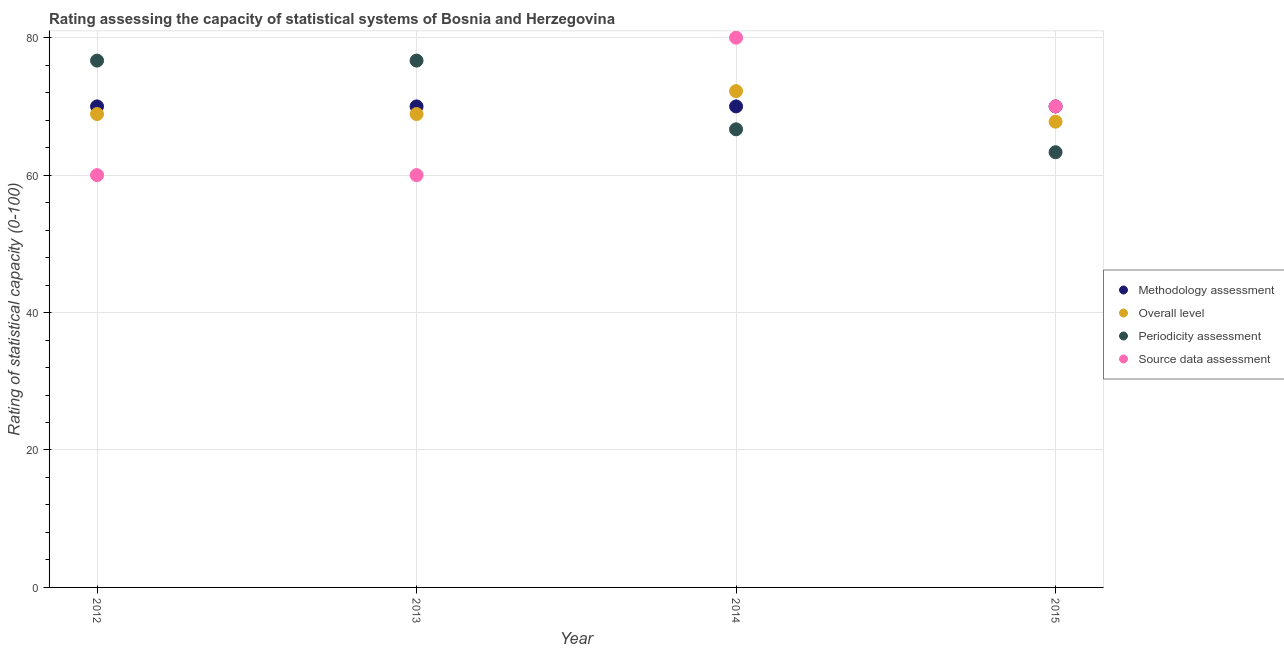What is the methodology assessment rating in 2014?
Make the answer very short. 70. Across all years, what is the maximum methodology assessment rating?
Your answer should be very brief. 70. Across all years, what is the minimum source data assessment rating?
Provide a short and direct response. 60. In which year was the periodicity assessment rating minimum?
Offer a terse response. 2015. What is the total overall level rating in the graph?
Give a very brief answer. 277.78. What is the difference between the source data assessment rating in 2014 and that in 2015?
Make the answer very short. 10. What is the difference between the methodology assessment rating in 2013 and the overall level rating in 2015?
Ensure brevity in your answer.  2.22. What is the average overall level rating per year?
Your answer should be compact. 69.44. In the year 2012, what is the difference between the periodicity assessment rating and methodology assessment rating?
Your response must be concise. 6.67. What is the ratio of the overall level rating in 2014 to that in 2015?
Your response must be concise. 1.07. Is the overall level rating in 2013 less than that in 2014?
Your answer should be compact. Yes. Is the difference between the periodicity assessment rating in 2013 and 2014 greater than the difference between the methodology assessment rating in 2013 and 2014?
Your response must be concise. Yes. What is the difference between the highest and the second highest periodicity assessment rating?
Provide a short and direct response. 3.3333332964957663e-6. What is the difference between the highest and the lowest methodology assessment rating?
Provide a succinct answer. 0. In how many years, is the methodology assessment rating greater than the average methodology assessment rating taken over all years?
Offer a very short reply. 0. Is the methodology assessment rating strictly greater than the periodicity assessment rating over the years?
Ensure brevity in your answer.  No. Is the overall level rating strictly less than the periodicity assessment rating over the years?
Offer a very short reply. No. How many years are there in the graph?
Your response must be concise. 4. What is the difference between two consecutive major ticks on the Y-axis?
Keep it short and to the point. 20. Are the values on the major ticks of Y-axis written in scientific E-notation?
Ensure brevity in your answer.  No. Where does the legend appear in the graph?
Offer a terse response. Center right. How many legend labels are there?
Your response must be concise. 4. What is the title of the graph?
Your answer should be compact. Rating assessing the capacity of statistical systems of Bosnia and Herzegovina. What is the label or title of the Y-axis?
Your answer should be very brief. Rating of statistical capacity (0-100). What is the Rating of statistical capacity (0-100) in Overall level in 2012?
Your answer should be compact. 68.89. What is the Rating of statistical capacity (0-100) of Periodicity assessment in 2012?
Your answer should be compact. 76.67. What is the Rating of statistical capacity (0-100) of Source data assessment in 2012?
Your response must be concise. 60. What is the Rating of statistical capacity (0-100) of Methodology assessment in 2013?
Your response must be concise. 70. What is the Rating of statistical capacity (0-100) in Overall level in 2013?
Ensure brevity in your answer.  68.89. What is the Rating of statistical capacity (0-100) of Periodicity assessment in 2013?
Give a very brief answer. 76.67. What is the Rating of statistical capacity (0-100) of Source data assessment in 2013?
Keep it short and to the point. 60. What is the Rating of statistical capacity (0-100) in Methodology assessment in 2014?
Provide a short and direct response. 70. What is the Rating of statistical capacity (0-100) in Overall level in 2014?
Provide a short and direct response. 72.22. What is the Rating of statistical capacity (0-100) in Periodicity assessment in 2014?
Ensure brevity in your answer.  66.67. What is the Rating of statistical capacity (0-100) of Source data assessment in 2014?
Make the answer very short. 80. What is the Rating of statistical capacity (0-100) in Methodology assessment in 2015?
Offer a terse response. 70. What is the Rating of statistical capacity (0-100) of Overall level in 2015?
Offer a terse response. 67.78. What is the Rating of statistical capacity (0-100) of Periodicity assessment in 2015?
Ensure brevity in your answer.  63.33. Across all years, what is the maximum Rating of statistical capacity (0-100) of Overall level?
Make the answer very short. 72.22. Across all years, what is the maximum Rating of statistical capacity (0-100) of Periodicity assessment?
Your response must be concise. 76.67. Across all years, what is the maximum Rating of statistical capacity (0-100) in Source data assessment?
Provide a short and direct response. 80. Across all years, what is the minimum Rating of statistical capacity (0-100) in Methodology assessment?
Your response must be concise. 70. Across all years, what is the minimum Rating of statistical capacity (0-100) in Overall level?
Ensure brevity in your answer.  67.78. Across all years, what is the minimum Rating of statistical capacity (0-100) of Periodicity assessment?
Ensure brevity in your answer.  63.33. What is the total Rating of statistical capacity (0-100) of Methodology assessment in the graph?
Your response must be concise. 280. What is the total Rating of statistical capacity (0-100) of Overall level in the graph?
Your answer should be very brief. 277.78. What is the total Rating of statistical capacity (0-100) in Periodicity assessment in the graph?
Provide a succinct answer. 283.33. What is the total Rating of statistical capacity (0-100) of Source data assessment in the graph?
Make the answer very short. 270. What is the difference between the Rating of statistical capacity (0-100) in Overall level in 2012 and that in 2013?
Your response must be concise. 0. What is the difference between the Rating of statistical capacity (0-100) of Overall level in 2012 and that in 2014?
Ensure brevity in your answer.  -3.33. What is the difference between the Rating of statistical capacity (0-100) in Source data assessment in 2012 and that in 2014?
Give a very brief answer. -20. What is the difference between the Rating of statistical capacity (0-100) in Periodicity assessment in 2012 and that in 2015?
Ensure brevity in your answer.  13.33. What is the difference between the Rating of statistical capacity (0-100) of Overall level in 2013 and that in 2014?
Provide a short and direct response. -3.33. What is the difference between the Rating of statistical capacity (0-100) in Periodicity assessment in 2013 and that in 2014?
Your response must be concise. 10. What is the difference between the Rating of statistical capacity (0-100) of Periodicity assessment in 2013 and that in 2015?
Offer a terse response. 13.33. What is the difference between the Rating of statistical capacity (0-100) in Source data assessment in 2013 and that in 2015?
Give a very brief answer. -10. What is the difference between the Rating of statistical capacity (0-100) of Overall level in 2014 and that in 2015?
Your answer should be compact. 4.44. What is the difference between the Rating of statistical capacity (0-100) in Periodicity assessment in 2014 and that in 2015?
Offer a terse response. 3.33. What is the difference between the Rating of statistical capacity (0-100) in Methodology assessment in 2012 and the Rating of statistical capacity (0-100) in Overall level in 2013?
Keep it short and to the point. 1.11. What is the difference between the Rating of statistical capacity (0-100) in Methodology assessment in 2012 and the Rating of statistical capacity (0-100) in Periodicity assessment in 2013?
Keep it short and to the point. -6.67. What is the difference between the Rating of statistical capacity (0-100) of Methodology assessment in 2012 and the Rating of statistical capacity (0-100) of Source data assessment in 2013?
Keep it short and to the point. 10. What is the difference between the Rating of statistical capacity (0-100) in Overall level in 2012 and the Rating of statistical capacity (0-100) in Periodicity assessment in 2013?
Give a very brief answer. -7.78. What is the difference between the Rating of statistical capacity (0-100) in Overall level in 2012 and the Rating of statistical capacity (0-100) in Source data assessment in 2013?
Ensure brevity in your answer.  8.89. What is the difference between the Rating of statistical capacity (0-100) of Periodicity assessment in 2012 and the Rating of statistical capacity (0-100) of Source data assessment in 2013?
Provide a short and direct response. 16.67. What is the difference between the Rating of statistical capacity (0-100) of Methodology assessment in 2012 and the Rating of statistical capacity (0-100) of Overall level in 2014?
Offer a very short reply. -2.22. What is the difference between the Rating of statistical capacity (0-100) of Methodology assessment in 2012 and the Rating of statistical capacity (0-100) of Periodicity assessment in 2014?
Ensure brevity in your answer.  3.33. What is the difference between the Rating of statistical capacity (0-100) in Methodology assessment in 2012 and the Rating of statistical capacity (0-100) in Source data assessment in 2014?
Give a very brief answer. -10. What is the difference between the Rating of statistical capacity (0-100) of Overall level in 2012 and the Rating of statistical capacity (0-100) of Periodicity assessment in 2014?
Offer a terse response. 2.22. What is the difference between the Rating of statistical capacity (0-100) in Overall level in 2012 and the Rating of statistical capacity (0-100) in Source data assessment in 2014?
Make the answer very short. -11.11. What is the difference between the Rating of statistical capacity (0-100) of Periodicity assessment in 2012 and the Rating of statistical capacity (0-100) of Source data assessment in 2014?
Offer a very short reply. -3.33. What is the difference between the Rating of statistical capacity (0-100) of Methodology assessment in 2012 and the Rating of statistical capacity (0-100) of Overall level in 2015?
Offer a terse response. 2.22. What is the difference between the Rating of statistical capacity (0-100) in Methodology assessment in 2012 and the Rating of statistical capacity (0-100) in Periodicity assessment in 2015?
Make the answer very short. 6.67. What is the difference between the Rating of statistical capacity (0-100) of Overall level in 2012 and the Rating of statistical capacity (0-100) of Periodicity assessment in 2015?
Your response must be concise. 5.56. What is the difference between the Rating of statistical capacity (0-100) of Overall level in 2012 and the Rating of statistical capacity (0-100) of Source data assessment in 2015?
Provide a succinct answer. -1.11. What is the difference between the Rating of statistical capacity (0-100) of Methodology assessment in 2013 and the Rating of statistical capacity (0-100) of Overall level in 2014?
Offer a very short reply. -2.22. What is the difference between the Rating of statistical capacity (0-100) in Methodology assessment in 2013 and the Rating of statistical capacity (0-100) in Periodicity assessment in 2014?
Offer a terse response. 3.33. What is the difference between the Rating of statistical capacity (0-100) in Methodology assessment in 2013 and the Rating of statistical capacity (0-100) in Source data assessment in 2014?
Offer a very short reply. -10. What is the difference between the Rating of statistical capacity (0-100) of Overall level in 2013 and the Rating of statistical capacity (0-100) of Periodicity assessment in 2014?
Keep it short and to the point. 2.22. What is the difference between the Rating of statistical capacity (0-100) of Overall level in 2013 and the Rating of statistical capacity (0-100) of Source data assessment in 2014?
Make the answer very short. -11.11. What is the difference between the Rating of statistical capacity (0-100) of Periodicity assessment in 2013 and the Rating of statistical capacity (0-100) of Source data assessment in 2014?
Provide a short and direct response. -3.33. What is the difference between the Rating of statistical capacity (0-100) of Methodology assessment in 2013 and the Rating of statistical capacity (0-100) of Overall level in 2015?
Your answer should be very brief. 2.22. What is the difference between the Rating of statistical capacity (0-100) of Methodology assessment in 2013 and the Rating of statistical capacity (0-100) of Periodicity assessment in 2015?
Keep it short and to the point. 6.67. What is the difference between the Rating of statistical capacity (0-100) in Methodology assessment in 2013 and the Rating of statistical capacity (0-100) in Source data assessment in 2015?
Offer a terse response. 0. What is the difference between the Rating of statistical capacity (0-100) in Overall level in 2013 and the Rating of statistical capacity (0-100) in Periodicity assessment in 2015?
Your response must be concise. 5.56. What is the difference between the Rating of statistical capacity (0-100) of Overall level in 2013 and the Rating of statistical capacity (0-100) of Source data assessment in 2015?
Your response must be concise. -1.11. What is the difference between the Rating of statistical capacity (0-100) in Periodicity assessment in 2013 and the Rating of statistical capacity (0-100) in Source data assessment in 2015?
Your response must be concise. 6.67. What is the difference between the Rating of statistical capacity (0-100) of Methodology assessment in 2014 and the Rating of statistical capacity (0-100) of Overall level in 2015?
Your response must be concise. 2.22. What is the difference between the Rating of statistical capacity (0-100) in Methodology assessment in 2014 and the Rating of statistical capacity (0-100) in Periodicity assessment in 2015?
Your response must be concise. 6.67. What is the difference between the Rating of statistical capacity (0-100) in Overall level in 2014 and the Rating of statistical capacity (0-100) in Periodicity assessment in 2015?
Offer a very short reply. 8.89. What is the difference between the Rating of statistical capacity (0-100) of Overall level in 2014 and the Rating of statistical capacity (0-100) of Source data assessment in 2015?
Provide a short and direct response. 2.22. What is the difference between the Rating of statistical capacity (0-100) of Periodicity assessment in 2014 and the Rating of statistical capacity (0-100) of Source data assessment in 2015?
Offer a terse response. -3.33. What is the average Rating of statistical capacity (0-100) in Overall level per year?
Provide a short and direct response. 69.44. What is the average Rating of statistical capacity (0-100) in Periodicity assessment per year?
Your answer should be very brief. 70.83. What is the average Rating of statistical capacity (0-100) of Source data assessment per year?
Ensure brevity in your answer.  67.5. In the year 2012, what is the difference between the Rating of statistical capacity (0-100) of Methodology assessment and Rating of statistical capacity (0-100) of Overall level?
Make the answer very short. 1.11. In the year 2012, what is the difference between the Rating of statistical capacity (0-100) in Methodology assessment and Rating of statistical capacity (0-100) in Periodicity assessment?
Provide a succinct answer. -6.67. In the year 2012, what is the difference between the Rating of statistical capacity (0-100) in Methodology assessment and Rating of statistical capacity (0-100) in Source data assessment?
Make the answer very short. 10. In the year 2012, what is the difference between the Rating of statistical capacity (0-100) of Overall level and Rating of statistical capacity (0-100) of Periodicity assessment?
Make the answer very short. -7.78. In the year 2012, what is the difference between the Rating of statistical capacity (0-100) of Overall level and Rating of statistical capacity (0-100) of Source data assessment?
Ensure brevity in your answer.  8.89. In the year 2012, what is the difference between the Rating of statistical capacity (0-100) of Periodicity assessment and Rating of statistical capacity (0-100) of Source data assessment?
Make the answer very short. 16.67. In the year 2013, what is the difference between the Rating of statistical capacity (0-100) of Methodology assessment and Rating of statistical capacity (0-100) of Periodicity assessment?
Make the answer very short. -6.67. In the year 2013, what is the difference between the Rating of statistical capacity (0-100) in Methodology assessment and Rating of statistical capacity (0-100) in Source data assessment?
Make the answer very short. 10. In the year 2013, what is the difference between the Rating of statistical capacity (0-100) of Overall level and Rating of statistical capacity (0-100) of Periodicity assessment?
Give a very brief answer. -7.78. In the year 2013, what is the difference between the Rating of statistical capacity (0-100) in Overall level and Rating of statistical capacity (0-100) in Source data assessment?
Your answer should be very brief. 8.89. In the year 2013, what is the difference between the Rating of statistical capacity (0-100) in Periodicity assessment and Rating of statistical capacity (0-100) in Source data assessment?
Offer a very short reply. 16.67. In the year 2014, what is the difference between the Rating of statistical capacity (0-100) in Methodology assessment and Rating of statistical capacity (0-100) in Overall level?
Provide a short and direct response. -2.22. In the year 2014, what is the difference between the Rating of statistical capacity (0-100) of Methodology assessment and Rating of statistical capacity (0-100) of Periodicity assessment?
Offer a very short reply. 3.33. In the year 2014, what is the difference between the Rating of statistical capacity (0-100) in Methodology assessment and Rating of statistical capacity (0-100) in Source data assessment?
Your response must be concise. -10. In the year 2014, what is the difference between the Rating of statistical capacity (0-100) of Overall level and Rating of statistical capacity (0-100) of Periodicity assessment?
Keep it short and to the point. 5.56. In the year 2014, what is the difference between the Rating of statistical capacity (0-100) of Overall level and Rating of statistical capacity (0-100) of Source data assessment?
Make the answer very short. -7.78. In the year 2014, what is the difference between the Rating of statistical capacity (0-100) in Periodicity assessment and Rating of statistical capacity (0-100) in Source data assessment?
Your answer should be compact. -13.33. In the year 2015, what is the difference between the Rating of statistical capacity (0-100) in Methodology assessment and Rating of statistical capacity (0-100) in Overall level?
Keep it short and to the point. 2.22. In the year 2015, what is the difference between the Rating of statistical capacity (0-100) of Methodology assessment and Rating of statistical capacity (0-100) of Periodicity assessment?
Offer a very short reply. 6.67. In the year 2015, what is the difference between the Rating of statistical capacity (0-100) of Overall level and Rating of statistical capacity (0-100) of Periodicity assessment?
Ensure brevity in your answer.  4.44. In the year 2015, what is the difference between the Rating of statistical capacity (0-100) of Overall level and Rating of statistical capacity (0-100) of Source data assessment?
Your response must be concise. -2.22. In the year 2015, what is the difference between the Rating of statistical capacity (0-100) of Periodicity assessment and Rating of statistical capacity (0-100) of Source data assessment?
Make the answer very short. -6.67. What is the ratio of the Rating of statistical capacity (0-100) in Methodology assessment in 2012 to that in 2013?
Provide a succinct answer. 1. What is the ratio of the Rating of statistical capacity (0-100) of Periodicity assessment in 2012 to that in 2013?
Ensure brevity in your answer.  1. What is the ratio of the Rating of statistical capacity (0-100) of Overall level in 2012 to that in 2014?
Provide a short and direct response. 0.95. What is the ratio of the Rating of statistical capacity (0-100) in Periodicity assessment in 2012 to that in 2014?
Your answer should be compact. 1.15. What is the ratio of the Rating of statistical capacity (0-100) of Source data assessment in 2012 to that in 2014?
Provide a short and direct response. 0.75. What is the ratio of the Rating of statistical capacity (0-100) in Overall level in 2012 to that in 2015?
Provide a short and direct response. 1.02. What is the ratio of the Rating of statistical capacity (0-100) in Periodicity assessment in 2012 to that in 2015?
Offer a very short reply. 1.21. What is the ratio of the Rating of statistical capacity (0-100) in Overall level in 2013 to that in 2014?
Offer a terse response. 0.95. What is the ratio of the Rating of statistical capacity (0-100) of Periodicity assessment in 2013 to that in 2014?
Ensure brevity in your answer.  1.15. What is the ratio of the Rating of statistical capacity (0-100) of Source data assessment in 2013 to that in 2014?
Your answer should be compact. 0.75. What is the ratio of the Rating of statistical capacity (0-100) in Methodology assessment in 2013 to that in 2015?
Your answer should be very brief. 1. What is the ratio of the Rating of statistical capacity (0-100) in Overall level in 2013 to that in 2015?
Make the answer very short. 1.02. What is the ratio of the Rating of statistical capacity (0-100) of Periodicity assessment in 2013 to that in 2015?
Offer a very short reply. 1.21. What is the ratio of the Rating of statistical capacity (0-100) of Source data assessment in 2013 to that in 2015?
Your answer should be compact. 0.86. What is the ratio of the Rating of statistical capacity (0-100) of Overall level in 2014 to that in 2015?
Offer a terse response. 1.07. What is the ratio of the Rating of statistical capacity (0-100) in Periodicity assessment in 2014 to that in 2015?
Provide a succinct answer. 1.05. What is the ratio of the Rating of statistical capacity (0-100) of Source data assessment in 2014 to that in 2015?
Provide a short and direct response. 1.14. What is the difference between the highest and the second highest Rating of statistical capacity (0-100) in Overall level?
Your response must be concise. 3.33. What is the difference between the highest and the second highest Rating of statistical capacity (0-100) in Periodicity assessment?
Ensure brevity in your answer.  0. What is the difference between the highest and the second highest Rating of statistical capacity (0-100) of Source data assessment?
Ensure brevity in your answer.  10. What is the difference between the highest and the lowest Rating of statistical capacity (0-100) of Overall level?
Keep it short and to the point. 4.44. What is the difference between the highest and the lowest Rating of statistical capacity (0-100) in Periodicity assessment?
Your response must be concise. 13.33. 